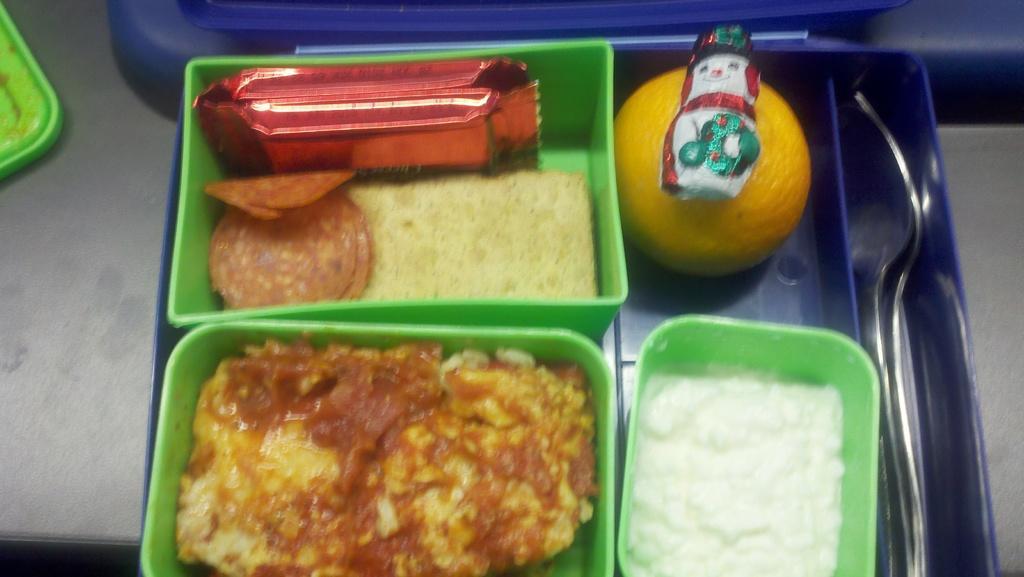Please provide a concise description of this image. In the foreground of the picture we can see plastic boxes, spoons, food items, fruit, packets and other objects. At the bottom there is a table. 